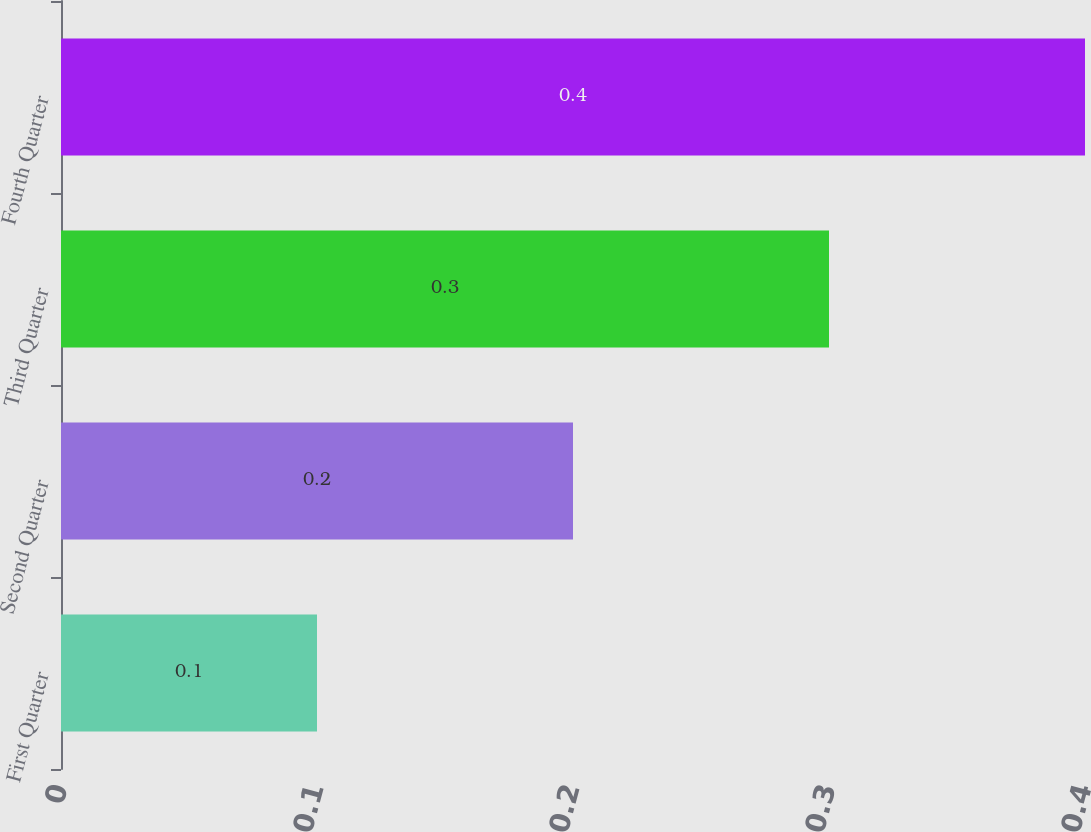Convert chart to OTSL. <chart><loc_0><loc_0><loc_500><loc_500><bar_chart><fcel>First Quarter<fcel>Second Quarter<fcel>Third Quarter<fcel>Fourth Quarter<nl><fcel>0.1<fcel>0.2<fcel>0.3<fcel>0.4<nl></chart> 